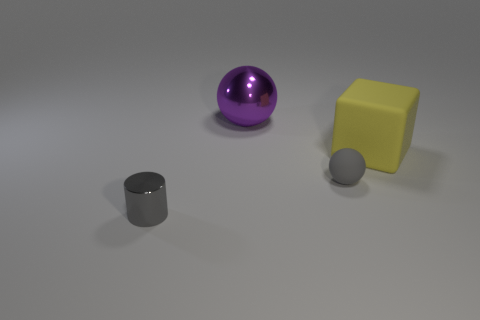The object that is behind the tiny gray sphere and to the right of the big purple metallic object has what shape?
Offer a very short reply. Cube. How many things are either yellow shiny cylinders or small gray objects left of the rubber sphere?
Provide a short and direct response. 1. There is a gray thing that is the same shape as the purple metal object; what material is it?
Your answer should be compact. Rubber. Is there anything else that is made of the same material as the large cube?
Ensure brevity in your answer.  Yes. There is a thing that is both behind the gray sphere and to the right of the purple metal thing; what material is it made of?
Keep it short and to the point. Rubber. How many small matte things have the same shape as the large purple object?
Ensure brevity in your answer.  1. The metallic thing in front of the rubber thing that is in front of the big rubber thing is what color?
Your answer should be compact. Gray. Is the number of gray shiny objects that are left of the tiny metallic cylinder the same as the number of large red metallic cylinders?
Offer a very short reply. Yes. Are there any rubber things that have the same size as the gray cylinder?
Keep it short and to the point. Yes. Does the matte cube have the same size as the sphere right of the big purple shiny ball?
Keep it short and to the point. No. 